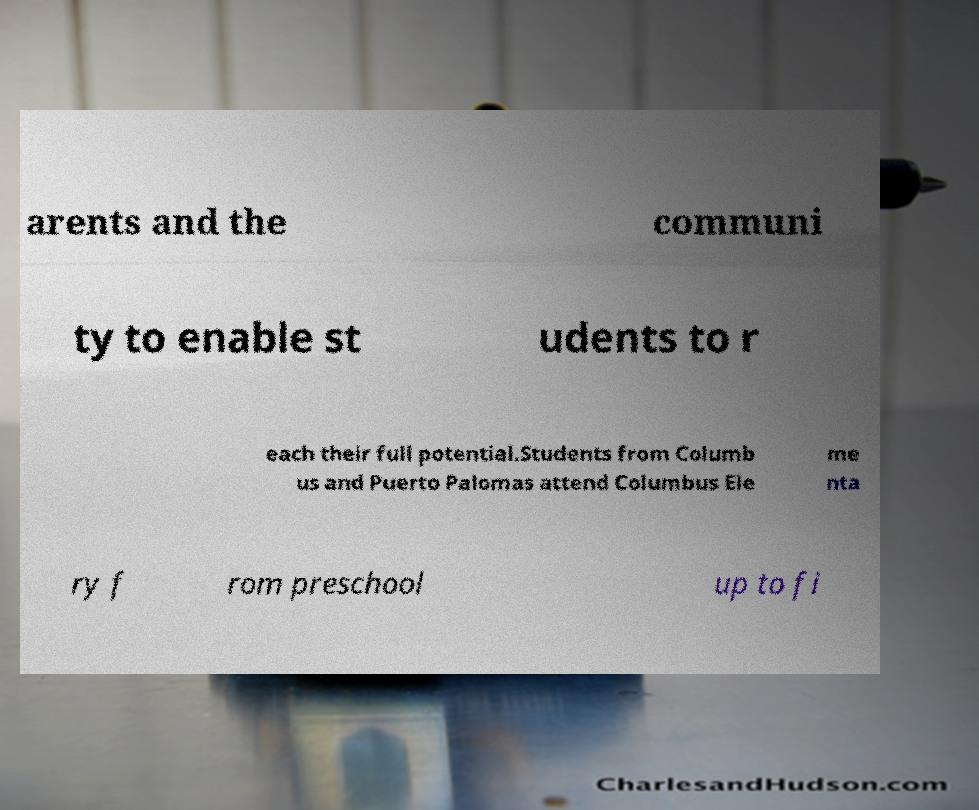Could you extract and type out the text from this image? arents and the communi ty to enable st udents to r each their full potential.Students from Columb us and Puerto Palomas attend Columbus Ele me nta ry f rom preschool up to fi 